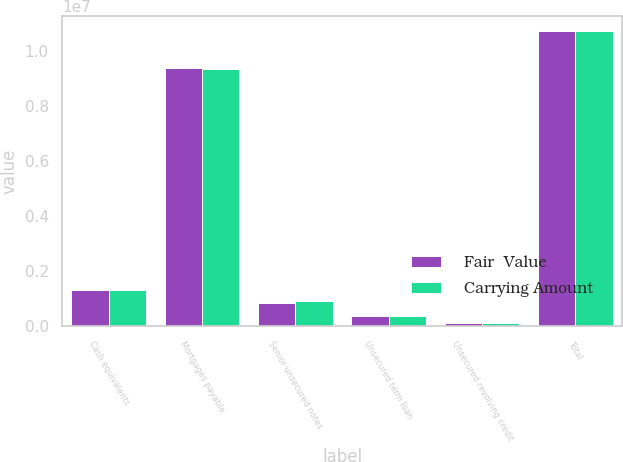<chart> <loc_0><loc_0><loc_500><loc_500><stacked_bar_chart><ecel><fcel>Cash equivalents<fcel>Mortgages payable<fcel>Senior unsecured notes<fcel>Unsecured term loan<fcel>Unsecured revolving credit<fcel>Total<nl><fcel>Fair  Value<fcel>1.3071e+06<fcel>9.3743e+06<fcel>850000<fcel>375000<fcel>115630<fcel>1.07149e+07<nl><fcel>Carrying Amount<fcel>1.307e+06<fcel>9.356e+06<fcel>899000<fcel>375000<fcel>116000<fcel>1.0746e+07<nl></chart> 